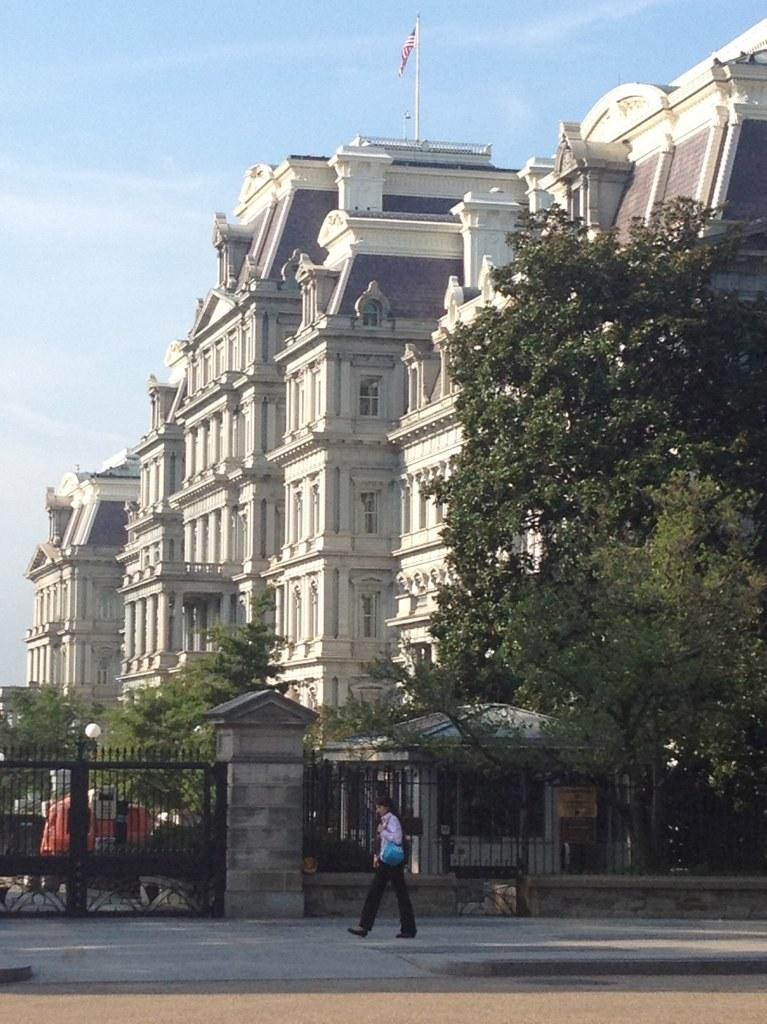Who or what is at the bottom of the image? There is a person at the bottom of the image. What is the person's position in relation to the other elements in the image? The person is at the bottom of the image. What structures can be seen in the image? There is a gate and an iron grill in the image. What can be seen in the background of the image? There are trees and buildings in the background of the image. What is at the top of the image? There is a flag at the top of the image, and the sky is also visible. What type of dress is the person wearing in the morning at the farm? There is no information about the person's dress, morning, or the presence of a farm in the image. 